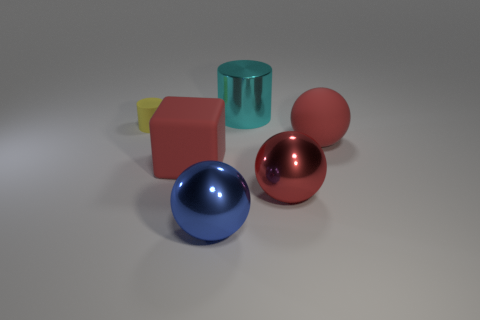Is there anything else that is the same size as the yellow object?
Give a very brief answer. No. What number of large rubber balls have the same color as the block?
Keep it short and to the point. 1. How big is the rubber thing that is both behind the red rubber cube and on the left side of the large blue metal thing?
Your response must be concise. Small. Is the number of small yellow rubber cylinders to the right of the blue shiny ball less than the number of large yellow matte things?
Provide a succinct answer. No. Are the small cylinder and the big red block made of the same material?
Offer a very short reply. Yes. What number of objects are big blue metallic cylinders or cyan things?
Make the answer very short. 1. How many large blue spheres have the same material as the blue object?
Keep it short and to the point. 0. There is a yellow thing that is the same shape as the cyan metal object; what size is it?
Ensure brevity in your answer.  Small. There is a blue metallic sphere; are there any metal balls to the left of it?
Provide a succinct answer. No. What material is the yellow cylinder?
Provide a short and direct response. Rubber. 